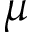<formula> <loc_0><loc_0><loc_500><loc_500>\mu</formula> 